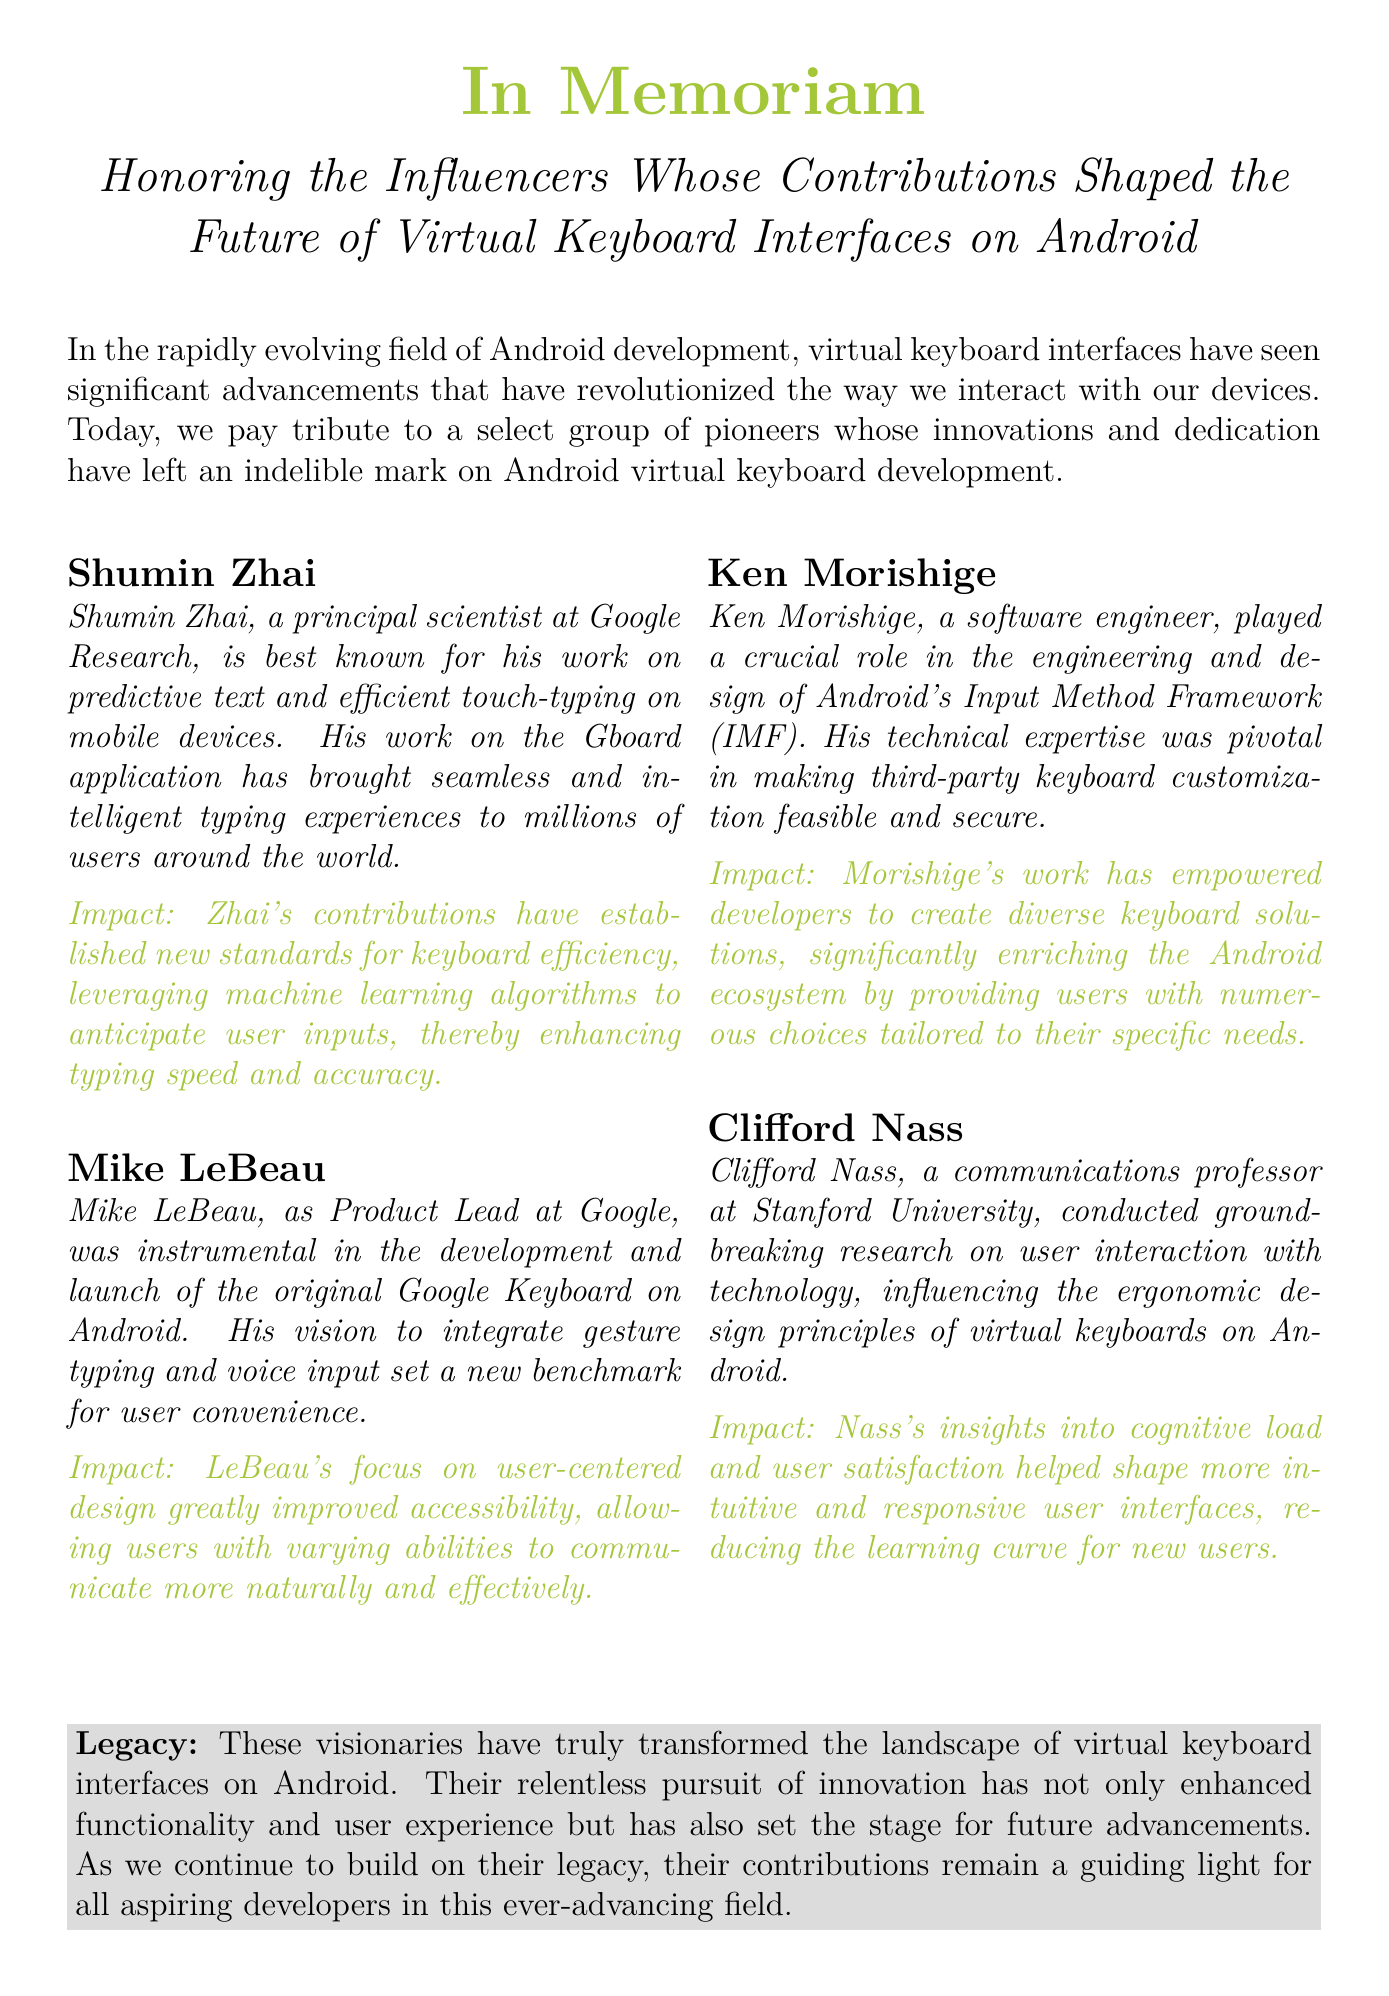What is the title of the document? The title is presented prominently at the top of the document, indicating the focus of the content.
Answer: In Memoriam Who is Shumin Zhai? Shumin Zhai is described in the document as a principal scientist at Google Research, recognized for his contributions to virtual keyboard interfaces.
Answer: principal scientist at Google Research What feature did Mike LeBeau integrate into the original Google Keyboard? The document specifically mentions a key innovation that LeBeau was part of during his role as Product Lead.
Answer: gesture typing and voice input Which framework did Ken Morishige work on? The document mentions the specific framework that Morishige contributed to, which is essential for keyboard development on Android.
Answer: Input Method Framework (IMF) What is the primary focus of Clifford Nass’s research? The document indicates that Nass’s research informed ergonomic design principles for a specific type of technology.
Answer: user interaction with technology How do Zhai's contributions impact typing? The document outlines how Zhai's innovations enhance a critical aspect of user experience in typing.
Answer: typing speed and accuracy What color is used for the 'Impact' section in the document? The document employs a specific color to differentiate the 'Impact' section, which can be identified visually.
Answer: androidgreen What does the document say about the legacy of these influencers? The document concludes with a statement regarding the ongoing significance of these influencers' work in a particular field.
Answer: transformed the landscape of virtual keyboard interfaces on Android 